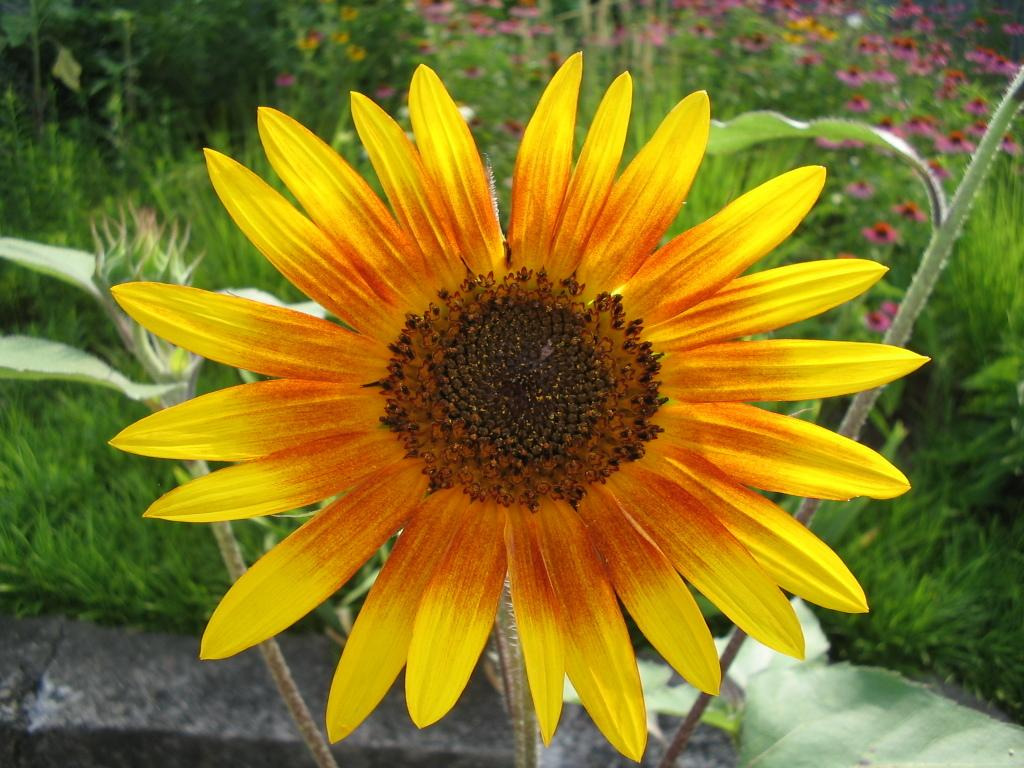What is the main subject of the image? There is a sunflower in the middle of the image. What color is the sunflower? The sunflower is yellow in color. What can be seen in the background of the image? There are plants in the background of the image. What type of screw can be seen holding the sunflower in place in the image? There is no screw present in the image; the sunflower is not held in place by any visible means. 